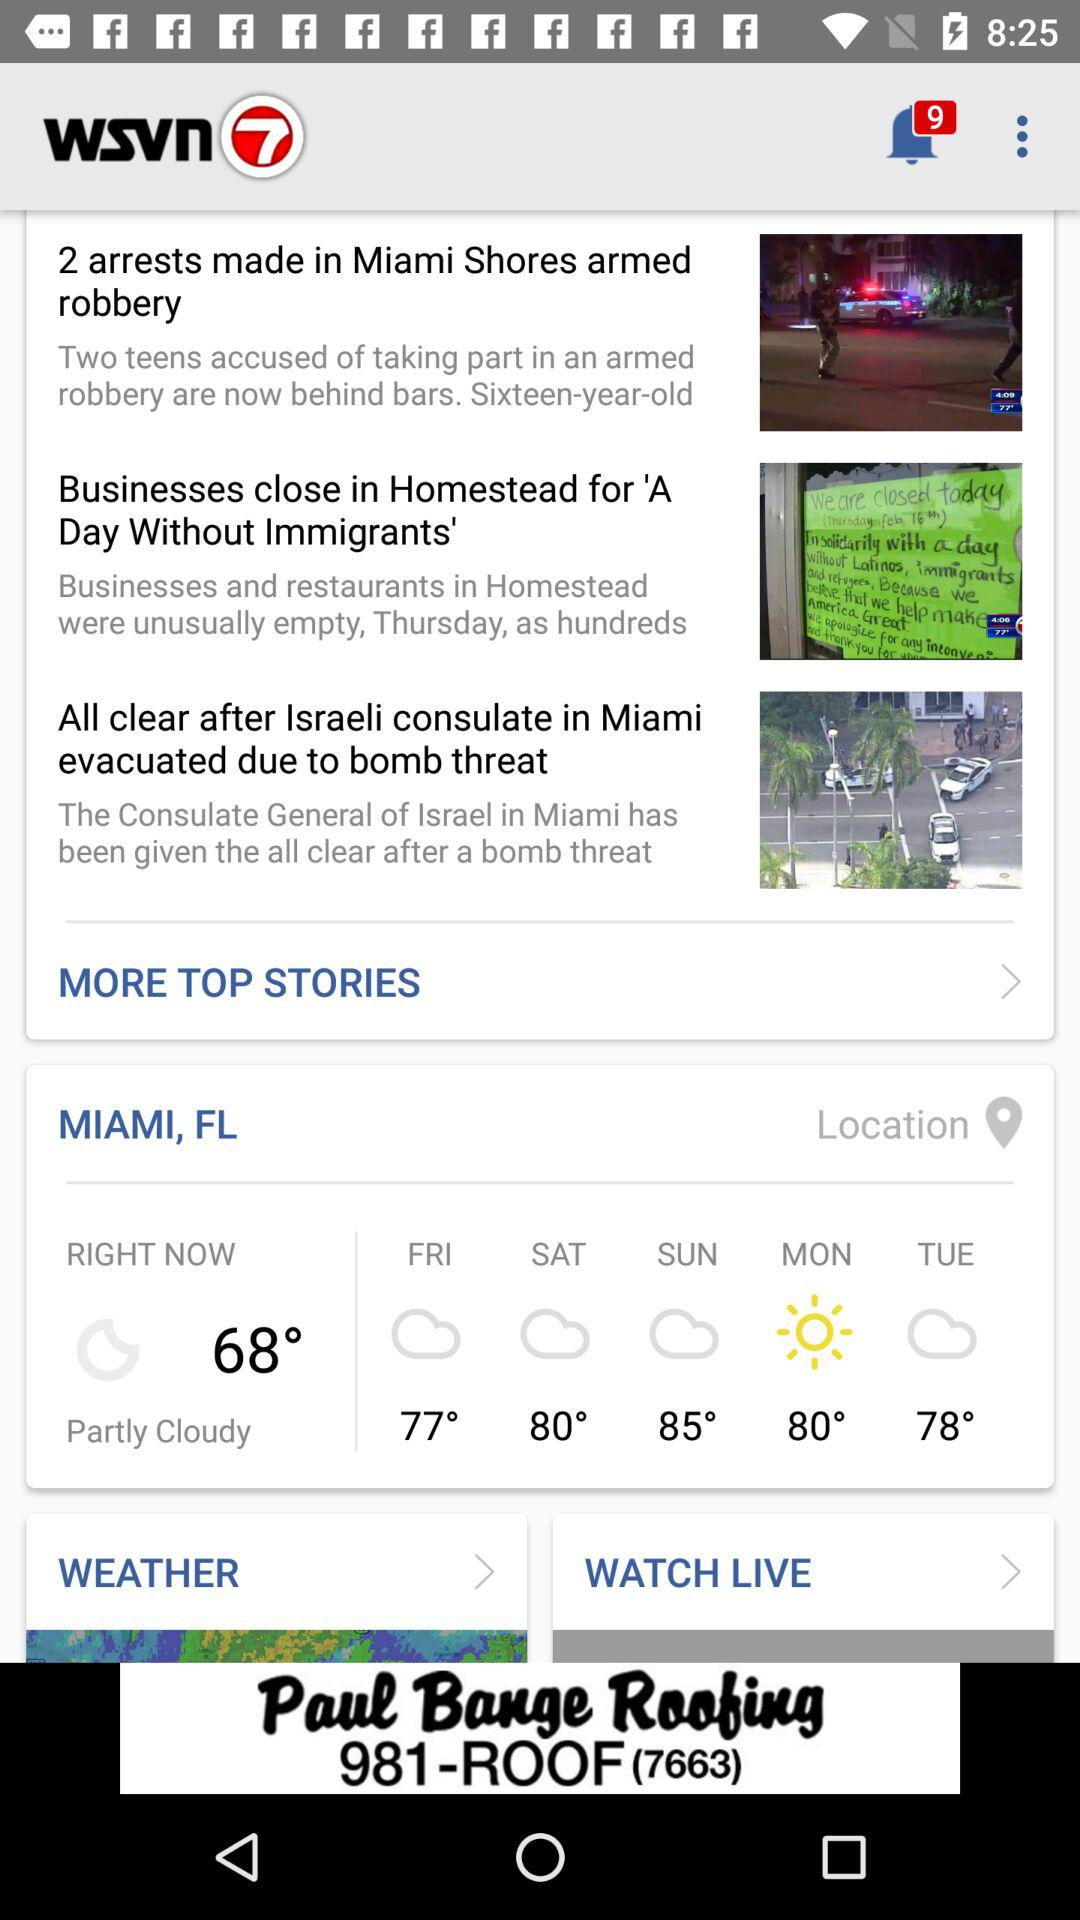What is the location given on the screen? The location given on the screen is Miami, FL. 